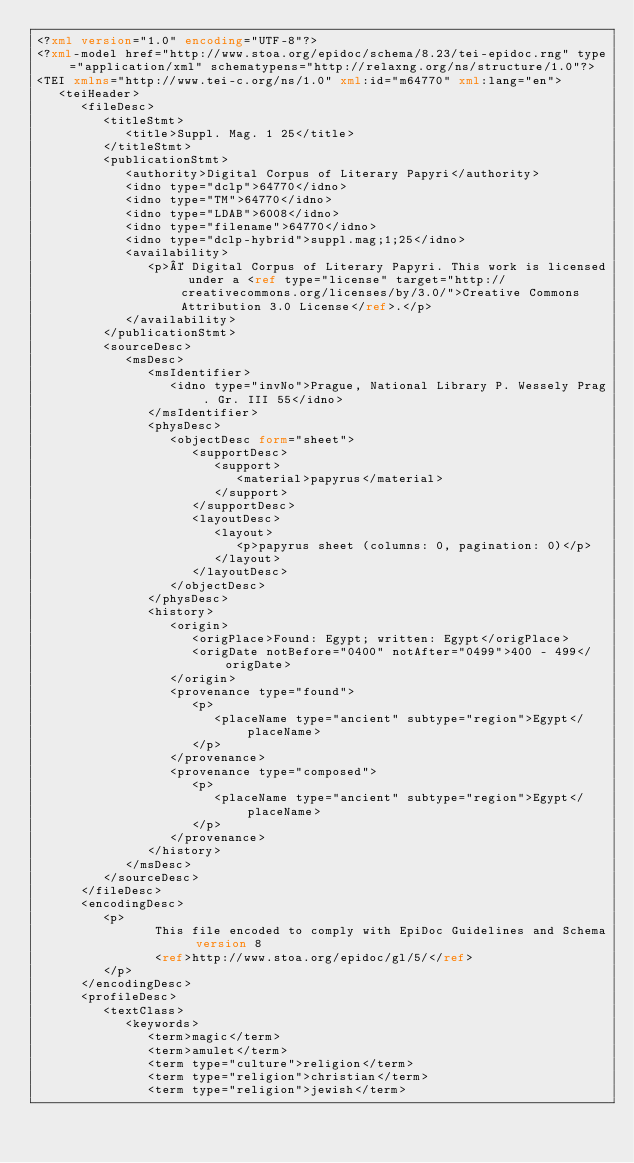<code> <loc_0><loc_0><loc_500><loc_500><_XML_><?xml version="1.0" encoding="UTF-8"?>
<?xml-model href="http://www.stoa.org/epidoc/schema/8.23/tei-epidoc.rng" type="application/xml" schematypens="http://relaxng.org/ns/structure/1.0"?>
<TEI xmlns="http://www.tei-c.org/ns/1.0" xml:id="m64770" xml:lang="en">
   <teiHeader>
      <fileDesc>
         <titleStmt>
            <title>Suppl. Mag. 1 25</title>
         </titleStmt>
         <publicationStmt>
            <authority>Digital Corpus of Literary Papyri</authority>
            <idno type="dclp">64770</idno>
            <idno type="TM">64770</idno>
            <idno type="LDAB">6008</idno>
            <idno type="filename">64770</idno>
            <idno type="dclp-hybrid">suppl.mag;1;25</idno>
            <availability>
               <p>© Digital Corpus of Literary Papyri. This work is licensed under a <ref type="license" target="http://creativecommons.org/licenses/by/3.0/">Creative Commons Attribution 3.0 License</ref>.</p>
            </availability>
         </publicationStmt>
         <sourceDesc>
            <msDesc>
               <msIdentifier>
                  <idno type="invNo">Prague, National Library P. Wessely Prag. Gr. III 55</idno>
               </msIdentifier>
               <physDesc>
                  <objectDesc form="sheet">
                     <supportDesc>
                        <support>
                           <material>papyrus</material>
                        </support>
                     </supportDesc>
                     <layoutDesc>
                        <layout>
                           <p>papyrus sheet (columns: 0, pagination: 0)</p>
                        </layout>
                     </layoutDesc>
                  </objectDesc>
               </physDesc>
               <history>
                  <origin>
                     <origPlace>Found: Egypt; written: Egypt</origPlace>
                     <origDate notBefore="0400" notAfter="0499">400 - 499</origDate>
                  </origin>
                  <provenance type="found">
                     <p>
                        <placeName type="ancient" subtype="region">Egypt</placeName>
                     </p>
                  </provenance>
                  <provenance type="composed">
                     <p>
                        <placeName type="ancient" subtype="region">Egypt</placeName>
                     </p>
                  </provenance>
               </history>
            </msDesc>
         </sourceDesc>
      </fileDesc>
      <encodingDesc>
         <p>
                This file encoded to comply with EpiDoc Guidelines and Schema version 8
                <ref>http://www.stoa.org/epidoc/gl/5/</ref>
         </p>
      </encodingDesc>
      <profileDesc>
         <textClass>
            <keywords>
               <term>magic</term>
               <term>amulet</term>
               <term type="culture">religion</term>
               <term type="religion">christian</term>
               <term type="religion">jewish</term></code> 